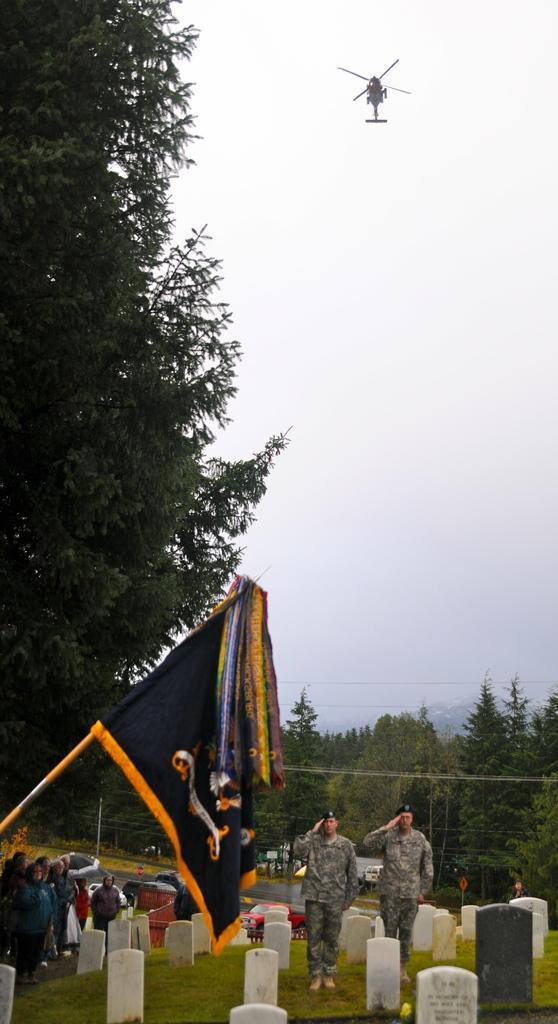How would you summarize this image in a sentence or two? In the image we can see there are two people standing, wearing army clothes, shoes and cap. Here we can see the flag and there are even other people wearing clothes. There are many memorials and trees. We can even see electrical wires, helicopter, grass and the sky. 